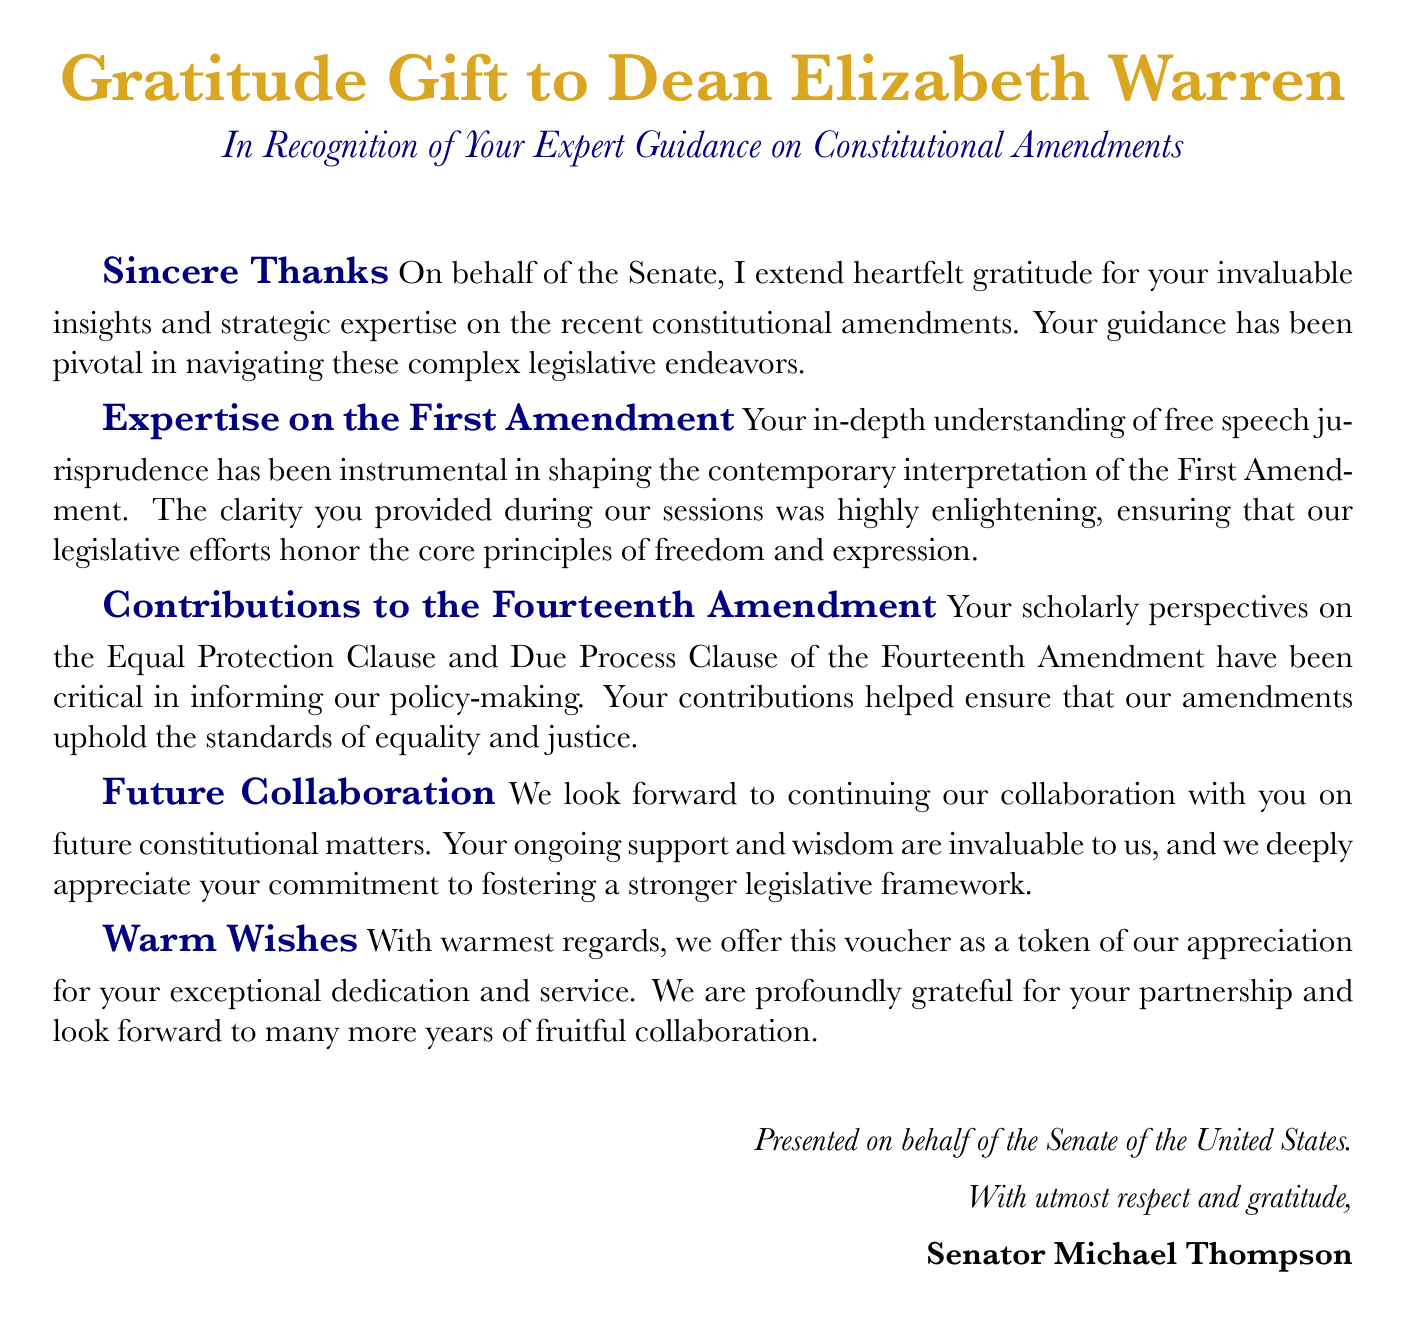What is the title of the document? The title is prominently displayed at the top of the document.
Answer: Gratitude Gift to Dean Elizabeth Warren Who is the recipient of the gift voucher? The recipient's name is mentioned in the document's title.
Answer: Dean Elizabeth Warren Which constitutional amendments did the document reference? The document mentions specific amendments in different sections.
Answer: First Amendment and Fourteenth Amendment Who presented the voucher? The presenter's name is listed at the end of the document.
Answer: Senator Michael Thompson What color is used for section titles? The color is specified in the document.
Answer: Navy blue What is the main purpose of this voucher? The purpose is summarized in the opening statement of the document.
Answer: To express gratitude for expert guidance How does the document describe Dean Warren’s contributions? This information is found in the sections detailing her expertise.
Answer: Pivotal and invaluable What is the tone of the document? The overall tone is articulated through the language used throughout the document.
Answer: Sincere and appreciative 